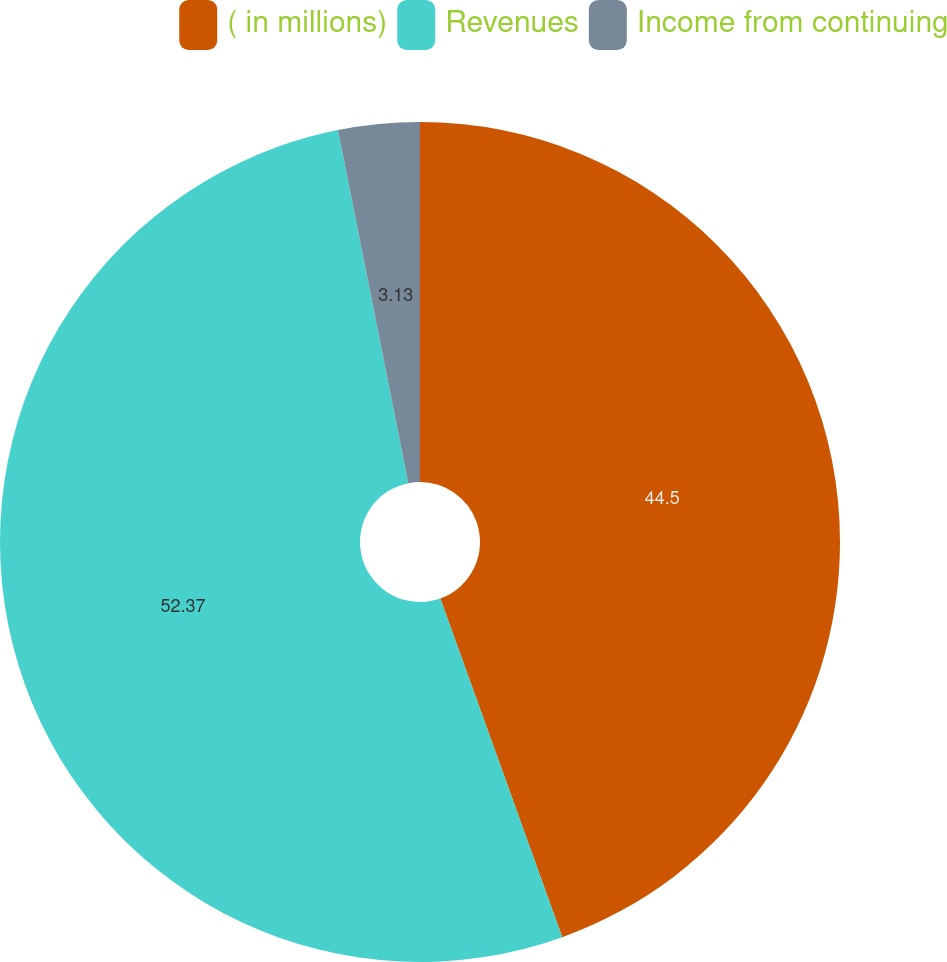Convert chart to OTSL. <chart><loc_0><loc_0><loc_500><loc_500><pie_chart><fcel>( in millions)<fcel>Revenues<fcel>Income from continuing<nl><fcel>44.5%<fcel>52.37%<fcel>3.13%<nl></chart> 